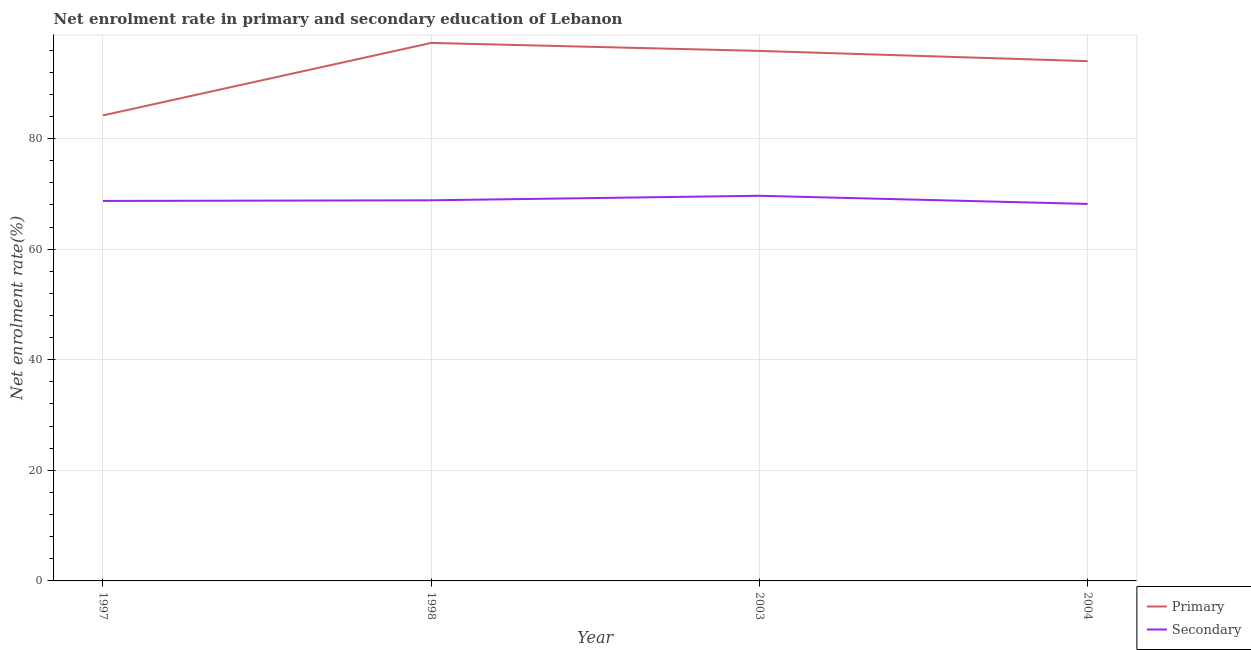How many different coloured lines are there?
Your answer should be compact. 2. Is the number of lines equal to the number of legend labels?
Offer a terse response. Yes. What is the enrollment rate in primary education in 2003?
Ensure brevity in your answer.  95.86. Across all years, what is the maximum enrollment rate in primary education?
Give a very brief answer. 97.3. Across all years, what is the minimum enrollment rate in secondary education?
Offer a terse response. 68.18. In which year was the enrollment rate in primary education minimum?
Offer a very short reply. 1997. What is the total enrollment rate in secondary education in the graph?
Offer a very short reply. 275.41. What is the difference between the enrollment rate in secondary education in 1998 and that in 2003?
Offer a terse response. -0.82. What is the difference between the enrollment rate in secondary education in 1997 and the enrollment rate in primary education in 1998?
Provide a short and direct response. -28.58. What is the average enrollment rate in secondary education per year?
Make the answer very short. 68.85. In the year 1997, what is the difference between the enrollment rate in primary education and enrollment rate in secondary education?
Make the answer very short. 15.47. What is the ratio of the enrollment rate in primary education in 1997 to that in 2003?
Offer a very short reply. 0.88. Is the enrollment rate in primary education in 1997 less than that in 2004?
Provide a short and direct response. Yes. What is the difference between the highest and the second highest enrollment rate in secondary education?
Provide a short and direct response. 0.82. What is the difference between the highest and the lowest enrollment rate in secondary education?
Offer a very short reply. 1.47. In how many years, is the enrollment rate in secondary education greater than the average enrollment rate in secondary education taken over all years?
Your response must be concise. 1. Is the sum of the enrollment rate in primary education in 1998 and 2003 greater than the maximum enrollment rate in secondary education across all years?
Your answer should be very brief. Yes. Does the enrollment rate in primary education monotonically increase over the years?
Offer a very short reply. No. How many lines are there?
Ensure brevity in your answer.  2. How many years are there in the graph?
Ensure brevity in your answer.  4. What is the difference between two consecutive major ticks on the Y-axis?
Your response must be concise. 20. Where does the legend appear in the graph?
Offer a terse response. Bottom right. How many legend labels are there?
Your response must be concise. 2. What is the title of the graph?
Provide a short and direct response. Net enrolment rate in primary and secondary education of Lebanon. Does "DAC donors" appear as one of the legend labels in the graph?
Ensure brevity in your answer.  No. What is the label or title of the X-axis?
Make the answer very short. Year. What is the label or title of the Y-axis?
Offer a very short reply. Net enrolment rate(%). What is the Net enrolment rate(%) in Primary in 1997?
Keep it short and to the point. 84.19. What is the Net enrolment rate(%) in Secondary in 1997?
Ensure brevity in your answer.  68.73. What is the Net enrolment rate(%) in Primary in 1998?
Offer a very short reply. 97.3. What is the Net enrolment rate(%) in Secondary in 1998?
Give a very brief answer. 68.84. What is the Net enrolment rate(%) in Primary in 2003?
Your answer should be compact. 95.86. What is the Net enrolment rate(%) of Secondary in 2003?
Keep it short and to the point. 69.66. What is the Net enrolment rate(%) of Primary in 2004?
Keep it short and to the point. 94.01. What is the Net enrolment rate(%) in Secondary in 2004?
Offer a very short reply. 68.18. Across all years, what is the maximum Net enrolment rate(%) in Primary?
Provide a succinct answer. 97.3. Across all years, what is the maximum Net enrolment rate(%) of Secondary?
Ensure brevity in your answer.  69.66. Across all years, what is the minimum Net enrolment rate(%) of Primary?
Your response must be concise. 84.19. Across all years, what is the minimum Net enrolment rate(%) in Secondary?
Give a very brief answer. 68.18. What is the total Net enrolment rate(%) in Primary in the graph?
Offer a terse response. 371.36. What is the total Net enrolment rate(%) in Secondary in the graph?
Give a very brief answer. 275.41. What is the difference between the Net enrolment rate(%) of Primary in 1997 and that in 1998?
Provide a short and direct response. -13.11. What is the difference between the Net enrolment rate(%) of Secondary in 1997 and that in 1998?
Make the answer very short. -0.12. What is the difference between the Net enrolment rate(%) in Primary in 1997 and that in 2003?
Offer a very short reply. -11.67. What is the difference between the Net enrolment rate(%) of Secondary in 1997 and that in 2003?
Give a very brief answer. -0.93. What is the difference between the Net enrolment rate(%) of Primary in 1997 and that in 2004?
Provide a succinct answer. -9.81. What is the difference between the Net enrolment rate(%) of Secondary in 1997 and that in 2004?
Make the answer very short. 0.54. What is the difference between the Net enrolment rate(%) of Primary in 1998 and that in 2003?
Offer a very short reply. 1.44. What is the difference between the Net enrolment rate(%) of Secondary in 1998 and that in 2003?
Ensure brevity in your answer.  -0.82. What is the difference between the Net enrolment rate(%) in Primary in 1998 and that in 2004?
Provide a short and direct response. 3.29. What is the difference between the Net enrolment rate(%) in Secondary in 1998 and that in 2004?
Offer a terse response. 0.66. What is the difference between the Net enrolment rate(%) in Primary in 2003 and that in 2004?
Provide a short and direct response. 1.85. What is the difference between the Net enrolment rate(%) in Secondary in 2003 and that in 2004?
Offer a terse response. 1.47. What is the difference between the Net enrolment rate(%) in Primary in 1997 and the Net enrolment rate(%) in Secondary in 1998?
Keep it short and to the point. 15.35. What is the difference between the Net enrolment rate(%) in Primary in 1997 and the Net enrolment rate(%) in Secondary in 2003?
Your answer should be very brief. 14.54. What is the difference between the Net enrolment rate(%) in Primary in 1997 and the Net enrolment rate(%) in Secondary in 2004?
Offer a terse response. 16.01. What is the difference between the Net enrolment rate(%) of Primary in 1998 and the Net enrolment rate(%) of Secondary in 2003?
Ensure brevity in your answer.  27.65. What is the difference between the Net enrolment rate(%) in Primary in 1998 and the Net enrolment rate(%) in Secondary in 2004?
Your answer should be compact. 29.12. What is the difference between the Net enrolment rate(%) in Primary in 2003 and the Net enrolment rate(%) in Secondary in 2004?
Your answer should be very brief. 27.67. What is the average Net enrolment rate(%) of Primary per year?
Your response must be concise. 92.84. What is the average Net enrolment rate(%) of Secondary per year?
Your response must be concise. 68.85. In the year 1997, what is the difference between the Net enrolment rate(%) of Primary and Net enrolment rate(%) of Secondary?
Keep it short and to the point. 15.47. In the year 1998, what is the difference between the Net enrolment rate(%) in Primary and Net enrolment rate(%) in Secondary?
Your answer should be very brief. 28.46. In the year 2003, what is the difference between the Net enrolment rate(%) of Primary and Net enrolment rate(%) of Secondary?
Offer a terse response. 26.2. In the year 2004, what is the difference between the Net enrolment rate(%) of Primary and Net enrolment rate(%) of Secondary?
Ensure brevity in your answer.  25.82. What is the ratio of the Net enrolment rate(%) of Primary in 1997 to that in 1998?
Provide a short and direct response. 0.87. What is the ratio of the Net enrolment rate(%) of Secondary in 1997 to that in 1998?
Keep it short and to the point. 1. What is the ratio of the Net enrolment rate(%) in Primary in 1997 to that in 2003?
Your answer should be compact. 0.88. What is the ratio of the Net enrolment rate(%) of Secondary in 1997 to that in 2003?
Your answer should be very brief. 0.99. What is the ratio of the Net enrolment rate(%) of Primary in 1997 to that in 2004?
Give a very brief answer. 0.9. What is the ratio of the Net enrolment rate(%) in Secondary in 1997 to that in 2004?
Keep it short and to the point. 1.01. What is the ratio of the Net enrolment rate(%) in Primary in 1998 to that in 2003?
Your response must be concise. 1.02. What is the ratio of the Net enrolment rate(%) of Secondary in 1998 to that in 2003?
Offer a very short reply. 0.99. What is the ratio of the Net enrolment rate(%) in Primary in 1998 to that in 2004?
Keep it short and to the point. 1.03. What is the ratio of the Net enrolment rate(%) of Secondary in 1998 to that in 2004?
Your answer should be very brief. 1.01. What is the ratio of the Net enrolment rate(%) in Primary in 2003 to that in 2004?
Make the answer very short. 1.02. What is the ratio of the Net enrolment rate(%) of Secondary in 2003 to that in 2004?
Make the answer very short. 1.02. What is the difference between the highest and the second highest Net enrolment rate(%) of Primary?
Keep it short and to the point. 1.44. What is the difference between the highest and the second highest Net enrolment rate(%) of Secondary?
Your answer should be very brief. 0.82. What is the difference between the highest and the lowest Net enrolment rate(%) of Primary?
Provide a succinct answer. 13.11. What is the difference between the highest and the lowest Net enrolment rate(%) in Secondary?
Provide a succinct answer. 1.47. 